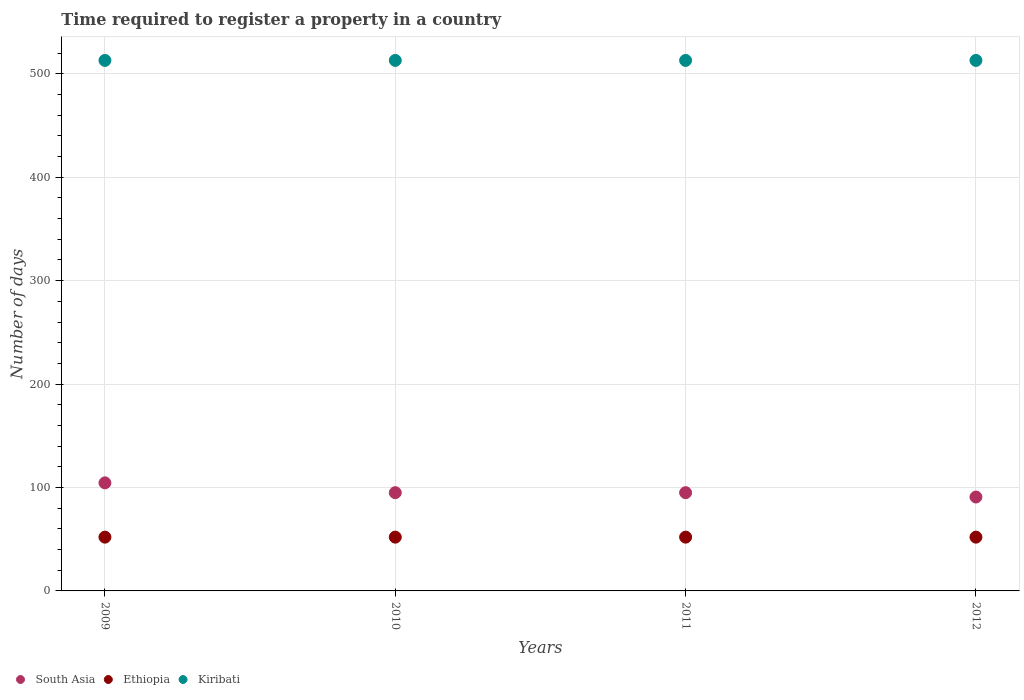How many different coloured dotlines are there?
Give a very brief answer. 3. Is the number of dotlines equal to the number of legend labels?
Provide a short and direct response. Yes. What is the number of days required to register a property in South Asia in 2012?
Ensure brevity in your answer.  90.8. Across all years, what is the maximum number of days required to register a property in South Asia?
Make the answer very short. 104.5. Across all years, what is the minimum number of days required to register a property in Ethiopia?
Give a very brief answer. 52. In which year was the number of days required to register a property in South Asia minimum?
Your answer should be very brief. 2012. What is the total number of days required to register a property in South Asia in the graph?
Your response must be concise. 385.3. What is the difference between the number of days required to register a property in South Asia in 2009 and that in 2011?
Provide a succinct answer. 9.5. What is the difference between the number of days required to register a property in South Asia in 2009 and the number of days required to register a property in Kiribati in 2010?
Your answer should be compact. -408.5. What is the average number of days required to register a property in Kiribati per year?
Your answer should be very brief. 513. In the year 2009, what is the difference between the number of days required to register a property in Kiribati and number of days required to register a property in Ethiopia?
Ensure brevity in your answer.  461. Is the number of days required to register a property in Ethiopia in 2011 less than that in 2012?
Offer a very short reply. No. Is the difference between the number of days required to register a property in Kiribati in 2009 and 2012 greater than the difference between the number of days required to register a property in Ethiopia in 2009 and 2012?
Offer a very short reply. No. What is the difference between the highest and the second highest number of days required to register a property in South Asia?
Keep it short and to the point. 9.5. What is the difference between the highest and the lowest number of days required to register a property in Ethiopia?
Your response must be concise. 0. Does the number of days required to register a property in South Asia monotonically increase over the years?
Provide a succinct answer. No. How many years are there in the graph?
Provide a short and direct response. 4. Does the graph contain grids?
Your answer should be compact. Yes. Where does the legend appear in the graph?
Keep it short and to the point. Bottom left. How many legend labels are there?
Give a very brief answer. 3. How are the legend labels stacked?
Ensure brevity in your answer.  Horizontal. What is the title of the graph?
Offer a terse response. Time required to register a property in a country. Does "Uruguay" appear as one of the legend labels in the graph?
Your answer should be very brief. No. What is the label or title of the Y-axis?
Your answer should be very brief. Number of days. What is the Number of days in South Asia in 2009?
Offer a terse response. 104.5. What is the Number of days in Kiribati in 2009?
Provide a short and direct response. 513. What is the Number of days of Ethiopia in 2010?
Your answer should be very brief. 52. What is the Number of days in Kiribati in 2010?
Your answer should be very brief. 513. What is the Number of days in South Asia in 2011?
Offer a very short reply. 95. What is the Number of days of Ethiopia in 2011?
Ensure brevity in your answer.  52. What is the Number of days in Kiribati in 2011?
Ensure brevity in your answer.  513. What is the Number of days of South Asia in 2012?
Give a very brief answer. 90.8. What is the Number of days of Kiribati in 2012?
Make the answer very short. 513. Across all years, what is the maximum Number of days of South Asia?
Your response must be concise. 104.5. Across all years, what is the maximum Number of days of Kiribati?
Your response must be concise. 513. Across all years, what is the minimum Number of days of South Asia?
Provide a succinct answer. 90.8. Across all years, what is the minimum Number of days in Ethiopia?
Give a very brief answer. 52. Across all years, what is the minimum Number of days in Kiribati?
Your response must be concise. 513. What is the total Number of days of South Asia in the graph?
Keep it short and to the point. 385.3. What is the total Number of days of Ethiopia in the graph?
Provide a succinct answer. 208. What is the total Number of days in Kiribati in the graph?
Provide a short and direct response. 2052. What is the difference between the Number of days of Ethiopia in 2009 and that in 2010?
Keep it short and to the point. 0. What is the difference between the Number of days of South Asia in 2009 and that in 2011?
Provide a succinct answer. 9.5. What is the difference between the Number of days of Ethiopia in 2009 and that in 2011?
Ensure brevity in your answer.  0. What is the difference between the Number of days of Ethiopia in 2009 and that in 2012?
Give a very brief answer. 0. What is the difference between the Number of days of South Asia in 2010 and that in 2011?
Keep it short and to the point. 0. What is the difference between the Number of days of Kiribati in 2010 and that in 2011?
Keep it short and to the point. 0. What is the difference between the Number of days of Kiribati in 2010 and that in 2012?
Your answer should be very brief. 0. What is the difference between the Number of days of South Asia in 2011 and that in 2012?
Make the answer very short. 4.2. What is the difference between the Number of days in Kiribati in 2011 and that in 2012?
Your answer should be very brief. 0. What is the difference between the Number of days in South Asia in 2009 and the Number of days in Ethiopia in 2010?
Provide a short and direct response. 52.5. What is the difference between the Number of days in South Asia in 2009 and the Number of days in Kiribati in 2010?
Keep it short and to the point. -408.5. What is the difference between the Number of days in Ethiopia in 2009 and the Number of days in Kiribati in 2010?
Offer a very short reply. -461. What is the difference between the Number of days in South Asia in 2009 and the Number of days in Ethiopia in 2011?
Keep it short and to the point. 52.5. What is the difference between the Number of days of South Asia in 2009 and the Number of days of Kiribati in 2011?
Your answer should be compact. -408.5. What is the difference between the Number of days in Ethiopia in 2009 and the Number of days in Kiribati in 2011?
Keep it short and to the point. -461. What is the difference between the Number of days of South Asia in 2009 and the Number of days of Ethiopia in 2012?
Give a very brief answer. 52.5. What is the difference between the Number of days in South Asia in 2009 and the Number of days in Kiribati in 2012?
Provide a succinct answer. -408.5. What is the difference between the Number of days in Ethiopia in 2009 and the Number of days in Kiribati in 2012?
Give a very brief answer. -461. What is the difference between the Number of days in South Asia in 2010 and the Number of days in Kiribati in 2011?
Keep it short and to the point. -418. What is the difference between the Number of days in Ethiopia in 2010 and the Number of days in Kiribati in 2011?
Ensure brevity in your answer.  -461. What is the difference between the Number of days of South Asia in 2010 and the Number of days of Ethiopia in 2012?
Offer a terse response. 43. What is the difference between the Number of days in South Asia in 2010 and the Number of days in Kiribati in 2012?
Ensure brevity in your answer.  -418. What is the difference between the Number of days in Ethiopia in 2010 and the Number of days in Kiribati in 2012?
Your answer should be compact. -461. What is the difference between the Number of days in South Asia in 2011 and the Number of days in Ethiopia in 2012?
Give a very brief answer. 43. What is the difference between the Number of days in South Asia in 2011 and the Number of days in Kiribati in 2012?
Offer a terse response. -418. What is the difference between the Number of days of Ethiopia in 2011 and the Number of days of Kiribati in 2012?
Keep it short and to the point. -461. What is the average Number of days in South Asia per year?
Your response must be concise. 96.33. What is the average Number of days of Kiribati per year?
Offer a terse response. 513. In the year 2009, what is the difference between the Number of days in South Asia and Number of days in Ethiopia?
Your answer should be compact. 52.5. In the year 2009, what is the difference between the Number of days of South Asia and Number of days of Kiribati?
Offer a terse response. -408.5. In the year 2009, what is the difference between the Number of days of Ethiopia and Number of days of Kiribati?
Your answer should be compact. -461. In the year 2010, what is the difference between the Number of days of South Asia and Number of days of Kiribati?
Make the answer very short. -418. In the year 2010, what is the difference between the Number of days in Ethiopia and Number of days in Kiribati?
Ensure brevity in your answer.  -461. In the year 2011, what is the difference between the Number of days of South Asia and Number of days of Ethiopia?
Make the answer very short. 43. In the year 2011, what is the difference between the Number of days of South Asia and Number of days of Kiribati?
Your response must be concise. -418. In the year 2011, what is the difference between the Number of days in Ethiopia and Number of days in Kiribati?
Provide a succinct answer. -461. In the year 2012, what is the difference between the Number of days of South Asia and Number of days of Ethiopia?
Give a very brief answer. 38.8. In the year 2012, what is the difference between the Number of days in South Asia and Number of days in Kiribati?
Provide a succinct answer. -422.2. In the year 2012, what is the difference between the Number of days of Ethiopia and Number of days of Kiribati?
Provide a succinct answer. -461. What is the ratio of the Number of days in Ethiopia in 2009 to that in 2010?
Keep it short and to the point. 1. What is the ratio of the Number of days of South Asia in 2009 to that in 2011?
Your answer should be very brief. 1.1. What is the ratio of the Number of days of South Asia in 2009 to that in 2012?
Give a very brief answer. 1.15. What is the ratio of the Number of days of Ethiopia in 2009 to that in 2012?
Your response must be concise. 1. What is the ratio of the Number of days of Kiribati in 2009 to that in 2012?
Give a very brief answer. 1. What is the ratio of the Number of days in South Asia in 2010 to that in 2011?
Provide a succinct answer. 1. What is the ratio of the Number of days in South Asia in 2010 to that in 2012?
Keep it short and to the point. 1.05. What is the ratio of the Number of days in South Asia in 2011 to that in 2012?
Your response must be concise. 1.05. What is the ratio of the Number of days of Kiribati in 2011 to that in 2012?
Keep it short and to the point. 1. What is the difference between the highest and the lowest Number of days in South Asia?
Offer a very short reply. 13.7. 